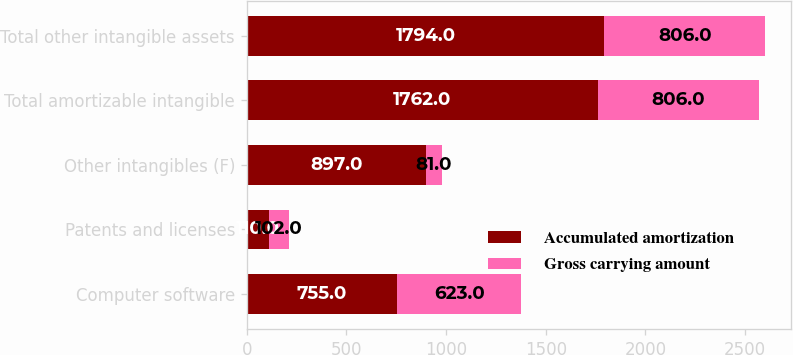Convert chart to OTSL. <chart><loc_0><loc_0><loc_500><loc_500><stacked_bar_chart><ecel><fcel>Computer software<fcel>Patents and licenses<fcel>Other intangibles (F)<fcel>Total amortizable intangible<fcel>Total other intangible assets<nl><fcel>Accumulated amortization<fcel>755<fcel>110<fcel>897<fcel>1762<fcel>1794<nl><fcel>Gross carrying amount<fcel>623<fcel>102<fcel>81<fcel>806<fcel>806<nl></chart> 